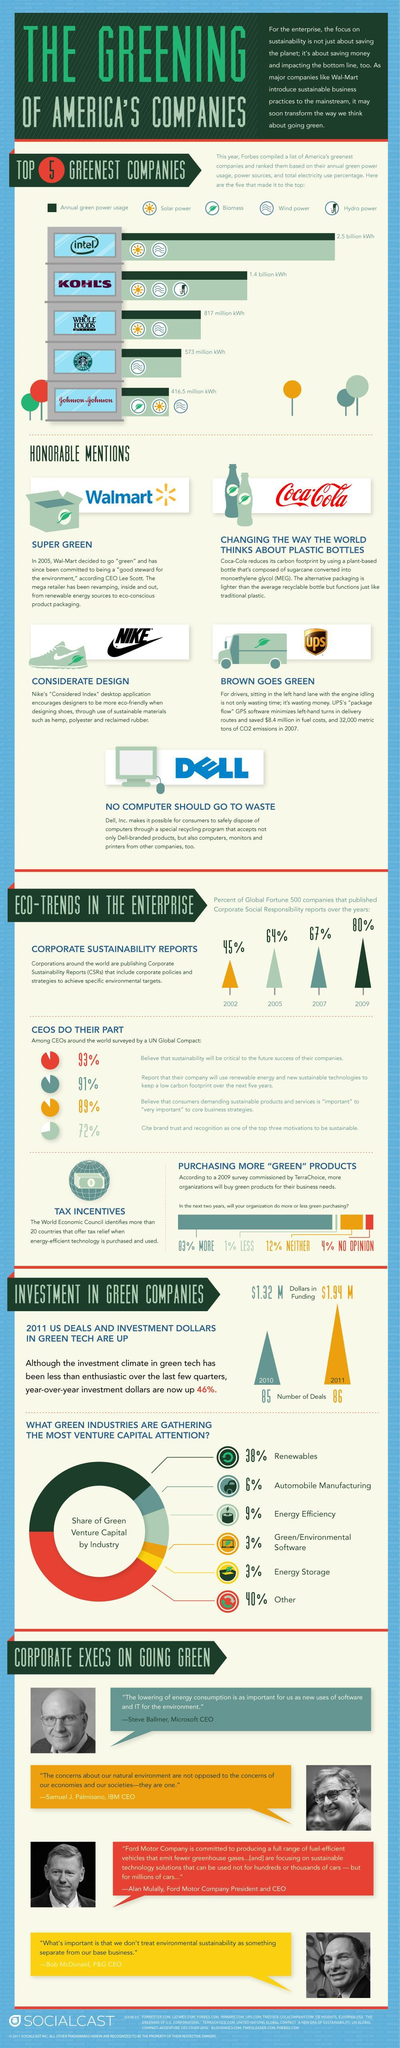Which green industry after other has the highest percentage of green capital ?
Answer the question with a short phrase. Renewables Which company has received an honorable mention for upgrading to a bottle derived from plants? Coca-Cola What is total percentage of companies that have no opinion and have not expressed interest or disinterest? 16% Which company uses biofuel to source its green power? Johnson & Johnson Which company uses green power using Wind as the source? STARBUCKS COFFEE What is the percentage green venture capital garnered by environmental software and energy storage? 3% What is percentage increase in the CSR initiatives of companies from 2007- 2009? 13% What a power sources Intel uses to generate green power? Solar power, Wind power 